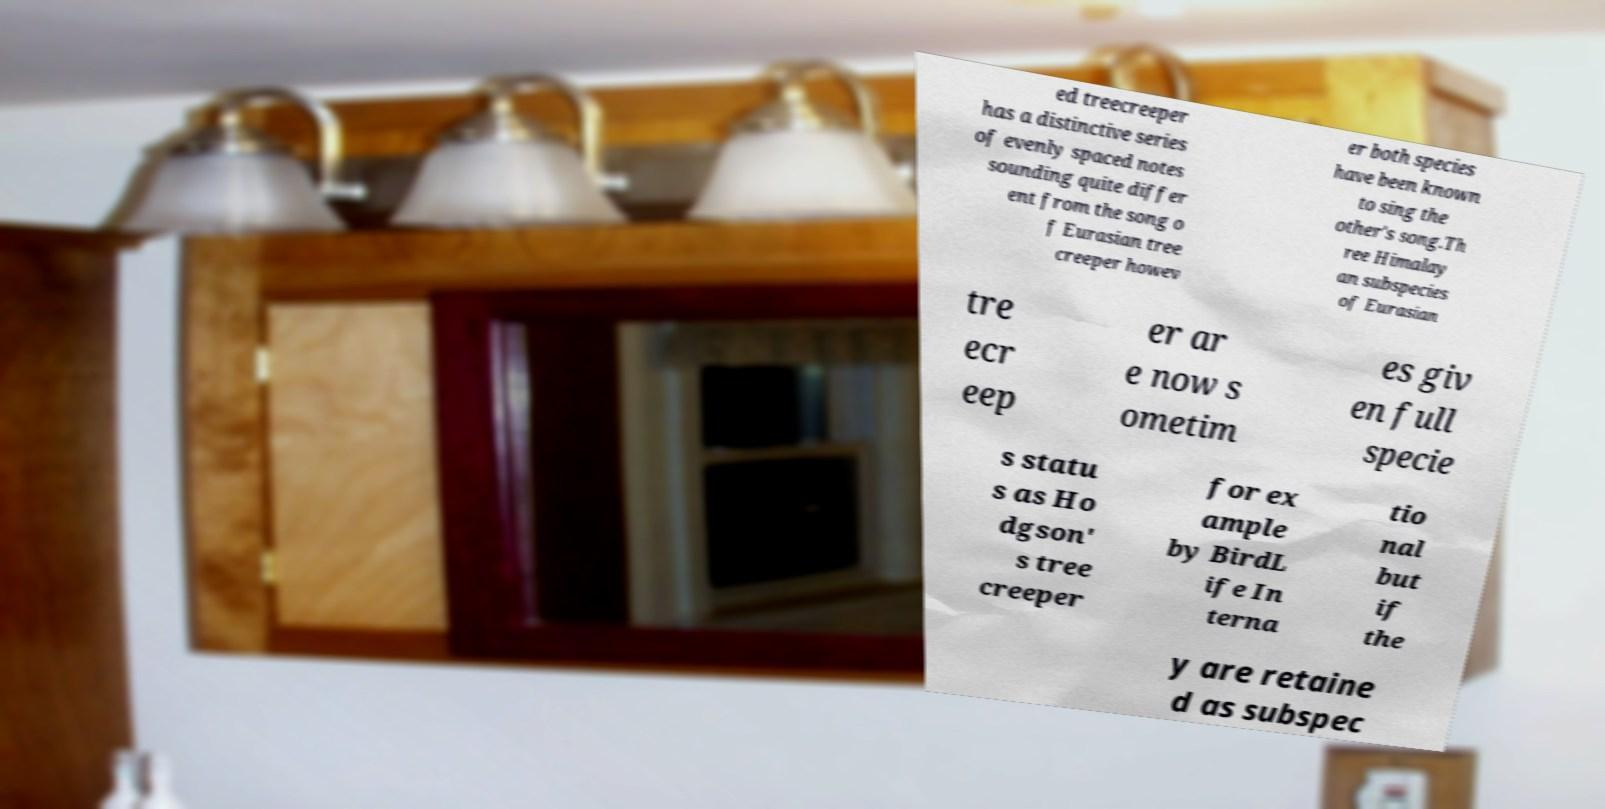For documentation purposes, I need the text within this image transcribed. Could you provide that? ed treecreeper has a distinctive series of evenly spaced notes sounding quite differ ent from the song o f Eurasian tree creeper howev er both species have been known to sing the other's song.Th ree Himalay an subspecies of Eurasian tre ecr eep er ar e now s ometim es giv en full specie s statu s as Ho dgson' s tree creeper for ex ample by BirdL ife In terna tio nal but if the y are retaine d as subspec 